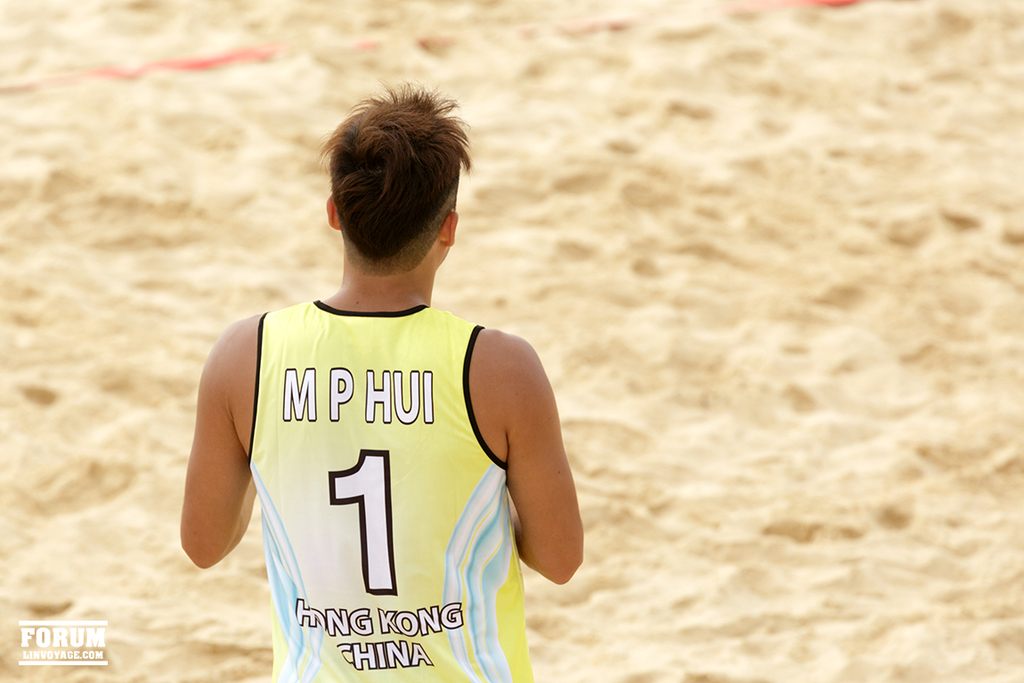Provide a one-sentence caption for the provided image. A focused athlete in a vibrant yellow jersey representing Hong Kong, China, stands pensively on a sandy volleyball court, contemplating his next move in the game. 